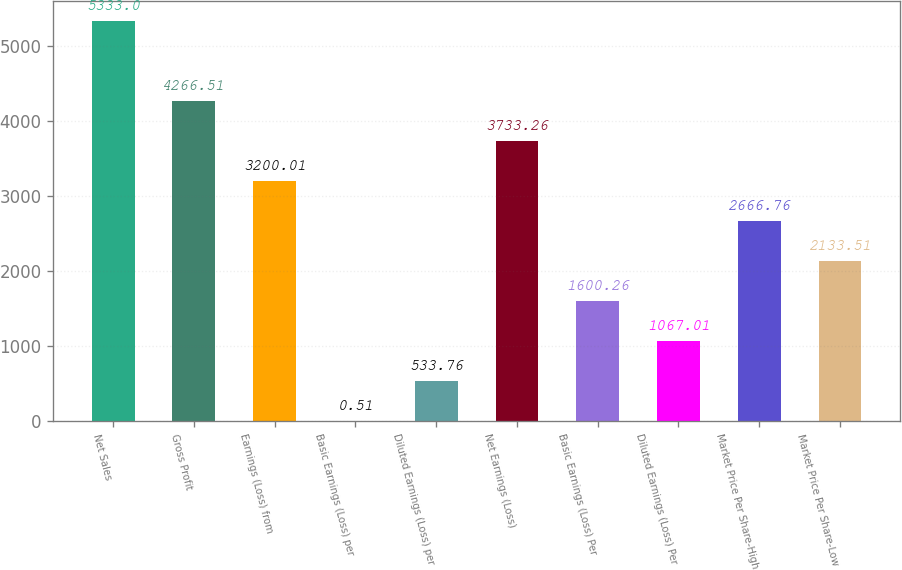Convert chart. <chart><loc_0><loc_0><loc_500><loc_500><bar_chart><fcel>Net Sales<fcel>Gross Profit<fcel>Earnings (Loss) from<fcel>Basic Earnings (Loss) per<fcel>Diluted Earnings (Loss) per<fcel>Net Earnings (Loss)<fcel>Basic Earnings (Loss) Per<fcel>Diluted Earnings (Loss) Per<fcel>Market Price Per Share-High<fcel>Market Price Per Share-Low<nl><fcel>5333<fcel>4266.51<fcel>3200.01<fcel>0.51<fcel>533.76<fcel>3733.26<fcel>1600.26<fcel>1067.01<fcel>2666.76<fcel>2133.51<nl></chart> 